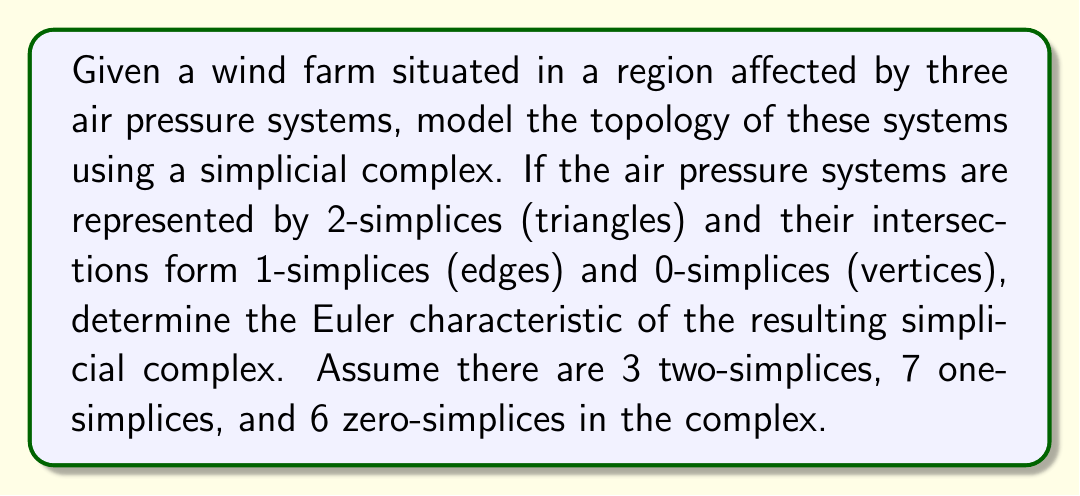Can you solve this math problem? To solve this problem, we need to understand the concept of Euler characteristic and how it applies to simplicial complexes representing air pressure systems.

1. The Euler characteristic ($\chi$) of a simplicial complex is defined as:

   $$\chi = \sum_{i=0}^{n} (-1)^i f_i$$

   where $f_i$ is the number of $i$-simplices in the complex.

2. In our case, we have:
   - $f_2 = 3$ (2-simplices / triangles)
   - $f_1 = 7$ (1-simplices / edges)
   - $f_0 = 6$ (0-simplices / vertices)

3. Let's substitute these values into the Euler characteristic formula:

   $$\chi = f_0 - f_1 + f_2$$

4. Now, we can calculate the Euler characteristic:

   $$\chi = 6 - 7 + 3 = 2$$

The Euler characteristic of 2 indicates that the topology of the air pressure systems is equivalent to a sphere. This makes sense in the context of meteorology, as air pressure systems on a global scale tend to form closed surfaces around the Earth.

For a meteorologist tracking wind patterns, this topology suggests that the wind farm is situated in an area where three major air pressure systems intersect, creating a complex wind pattern that could significantly affect the farm's energy production.
Answer: The Euler characteristic of the simplicial complex representing the air pressure systems is 2. 